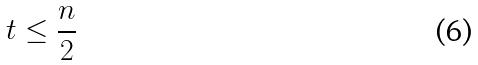<formula> <loc_0><loc_0><loc_500><loc_500>t \leq \frac { n } { 2 }</formula> 